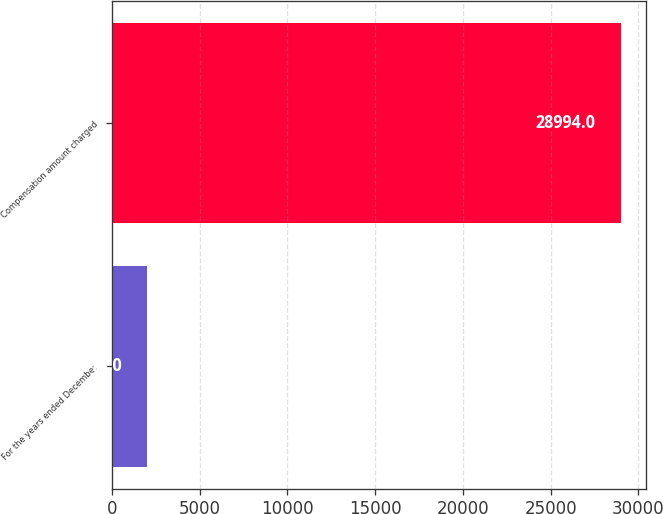Convert chart to OTSL. <chart><loc_0><loc_0><loc_500><loc_500><bar_chart><fcel>For the years ended December<fcel>Compensation amount charged<nl><fcel>2014<fcel>28994<nl></chart> 